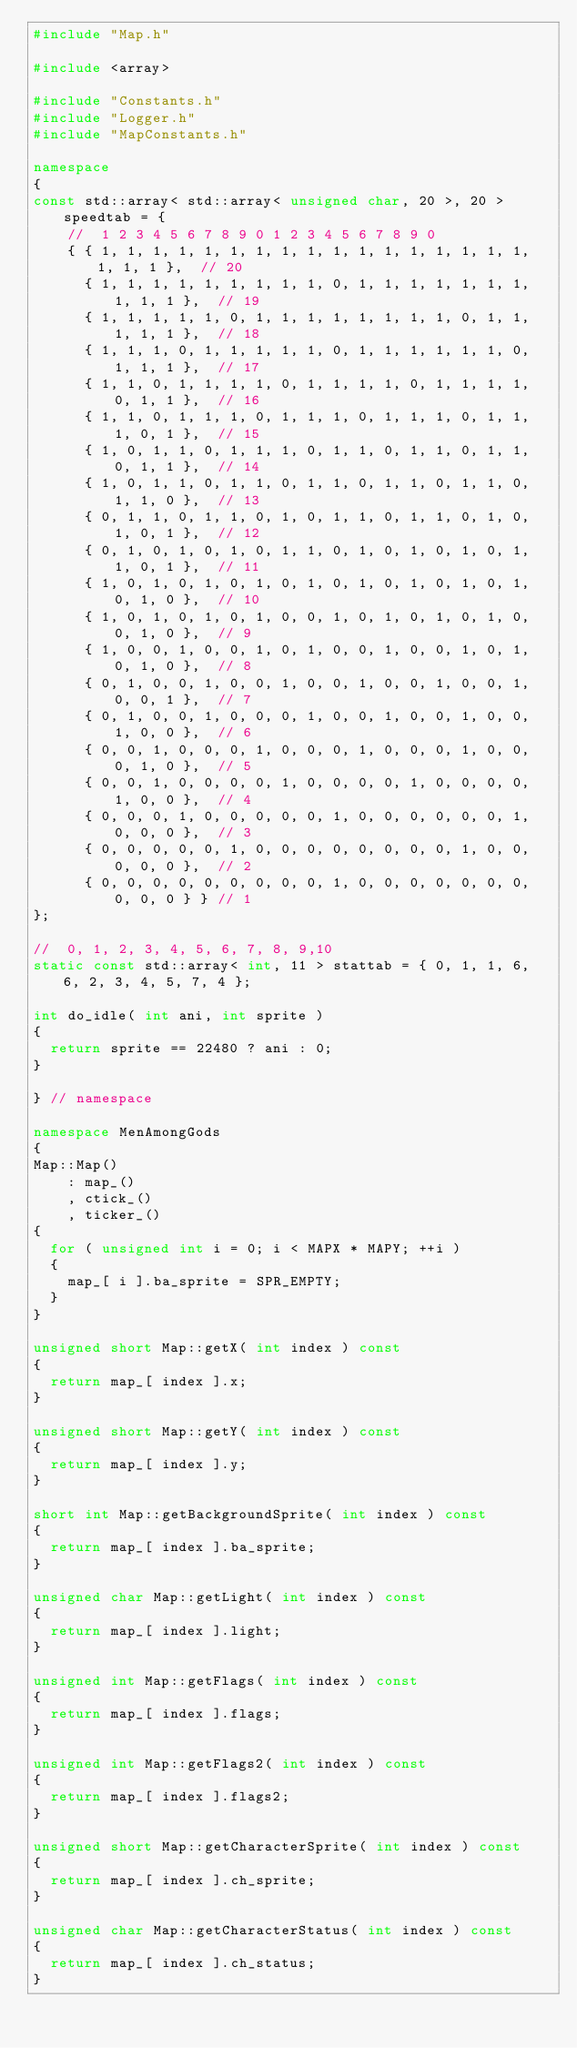<code> <loc_0><loc_0><loc_500><loc_500><_C++_>#include "Map.h"

#include <array>

#include "Constants.h"
#include "Logger.h"
#include "MapConstants.h"

namespace
{
const std::array< std::array< unsigned char, 20 >, 20 > speedtab = {
    //  1 2 3 4 5 6 7 8 9 0 1 2 3 4 5 6 7 8 9 0
    { { 1, 1, 1, 1, 1, 1, 1, 1, 1, 1, 1, 1, 1, 1, 1, 1, 1, 1, 1, 1 },  // 20
      { 1, 1, 1, 1, 1, 1, 1, 1, 1, 0, 1, 1, 1, 1, 1, 1, 1, 1, 1, 1 },  // 19
      { 1, 1, 1, 1, 1, 0, 1, 1, 1, 1, 1, 1, 1, 1, 0, 1, 1, 1, 1, 1 },  // 18
      { 1, 1, 1, 0, 1, 1, 1, 1, 1, 0, 1, 1, 1, 1, 1, 1, 0, 1, 1, 1 },  // 17
      { 1, 1, 0, 1, 1, 1, 1, 0, 1, 1, 1, 1, 0, 1, 1, 1, 1, 0, 1, 1 },  // 16
      { 1, 1, 0, 1, 1, 1, 0, 1, 1, 1, 0, 1, 1, 1, 0, 1, 1, 1, 0, 1 },  // 15
      { 1, 0, 1, 1, 0, 1, 1, 1, 0, 1, 1, 0, 1, 1, 0, 1, 1, 0, 1, 1 },  // 14
      { 1, 0, 1, 1, 0, 1, 1, 0, 1, 1, 0, 1, 1, 0, 1, 1, 0, 1, 1, 0 },  // 13
      { 0, 1, 1, 0, 1, 1, 0, 1, 0, 1, 1, 0, 1, 1, 0, 1, 0, 1, 0, 1 },  // 12
      { 0, 1, 0, 1, 0, 1, 0, 1, 1, 0, 1, 0, 1, 0, 1, 0, 1, 1, 0, 1 },  // 11
      { 1, 0, 1, 0, 1, 0, 1, 0, 1, 0, 1, 0, 1, 0, 1, 0, 1, 0, 1, 0 },  // 10
      { 1, 0, 1, 0, 1, 0, 1, 0, 0, 1, 0, 1, 0, 1, 0, 1, 0, 0, 1, 0 },  // 9
      { 1, 0, 0, 1, 0, 0, 1, 0, 1, 0, 0, 1, 0, 0, 1, 0, 1, 0, 1, 0 },  // 8
      { 0, 1, 0, 0, 1, 0, 0, 1, 0, 0, 1, 0, 0, 1, 0, 0, 1, 0, 0, 1 },  // 7
      { 0, 1, 0, 0, 1, 0, 0, 0, 1, 0, 0, 1, 0, 0, 1, 0, 0, 1, 0, 0 },  // 6
      { 0, 0, 1, 0, 0, 0, 1, 0, 0, 0, 1, 0, 0, 0, 1, 0, 0, 0, 1, 0 },  // 5
      { 0, 0, 1, 0, 0, 0, 0, 1, 0, 0, 0, 0, 1, 0, 0, 0, 0, 1, 0, 0 },  // 4
      { 0, 0, 0, 1, 0, 0, 0, 0, 0, 1, 0, 0, 0, 0, 0, 0, 1, 0, 0, 0 },  // 3
      { 0, 0, 0, 0, 0, 1, 0, 0, 0, 0, 0, 0, 0, 0, 1, 0, 0, 0, 0, 0 },  // 2
      { 0, 0, 0, 0, 0, 0, 0, 0, 0, 1, 0, 0, 0, 0, 0, 0, 0, 0, 0, 0 } } // 1
};

//  0, 1, 2, 3, 4, 5, 6, 7, 8, 9,10
static const std::array< int, 11 > stattab = { 0, 1, 1, 6, 6, 2, 3, 4, 5, 7, 4 };

int do_idle( int ani, int sprite )
{
  return sprite == 22480 ? ani : 0;
}

} // namespace

namespace MenAmongGods
{
Map::Map()
    : map_()
    , ctick_()
    , ticker_()
{
  for ( unsigned int i = 0; i < MAPX * MAPY; ++i )
  {
    map_[ i ].ba_sprite = SPR_EMPTY;
  }
}

unsigned short Map::getX( int index ) const
{
  return map_[ index ].x;
}

unsigned short Map::getY( int index ) const
{
  return map_[ index ].y;
}

short int Map::getBackgroundSprite( int index ) const
{
  return map_[ index ].ba_sprite;
}

unsigned char Map::getLight( int index ) const
{
  return map_[ index ].light;
}

unsigned int Map::getFlags( int index ) const
{
  return map_[ index ].flags;
}

unsigned int Map::getFlags2( int index ) const
{
  return map_[ index ].flags2;
}

unsigned short Map::getCharacterSprite( int index ) const
{
  return map_[ index ].ch_sprite;
}

unsigned char Map::getCharacterStatus( int index ) const
{
  return map_[ index ].ch_status;
}
</code> 